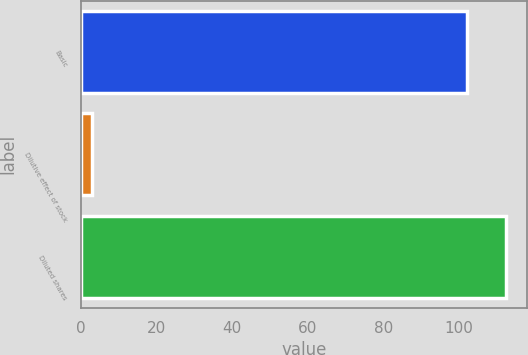<chart> <loc_0><loc_0><loc_500><loc_500><bar_chart><fcel>Basic<fcel>Dilutive effect of stock<fcel>Diluted shares<nl><fcel>102.3<fcel>2.9<fcel>112.53<nl></chart> 